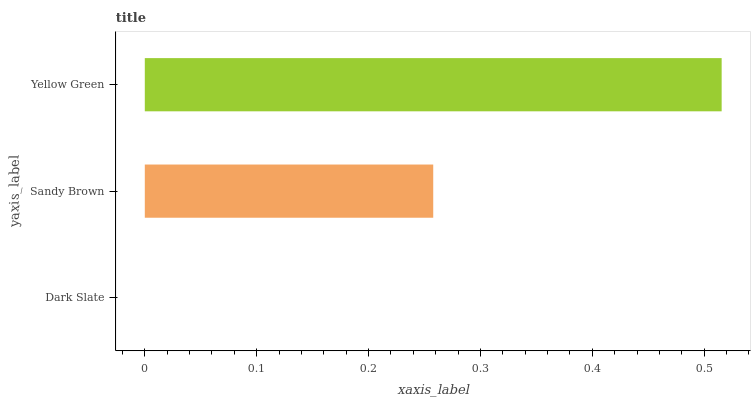Is Dark Slate the minimum?
Answer yes or no. Yes. Is Yellow Green the maximum?
Answer yes or no. Yes. Is Sandy Brown the minimum?
Answer yes or no. No. Is Sandy Brown the maximum?
Answer yes or no. No. Is Sandy Brown greater than Dark Slate?
Answer yes or no. Yes. Is Dark Slate less than Sandy Brown?
Answer yes or no. Yes. Is Dark Slate greater than Sandy Brown?
Answer yes or no. No. Is Sandy Brown less than Dark Slate?
Answer yes or no. No. Is Sandy Brown the high median?
Answer yes or no. Yes. Is Sandy Brown the low median?
Answer yes or no. Yes. Is Yellow Green the high median?
Answer yes or no. No. Is Dark Slate the low median?
Answer yes or no. No. 